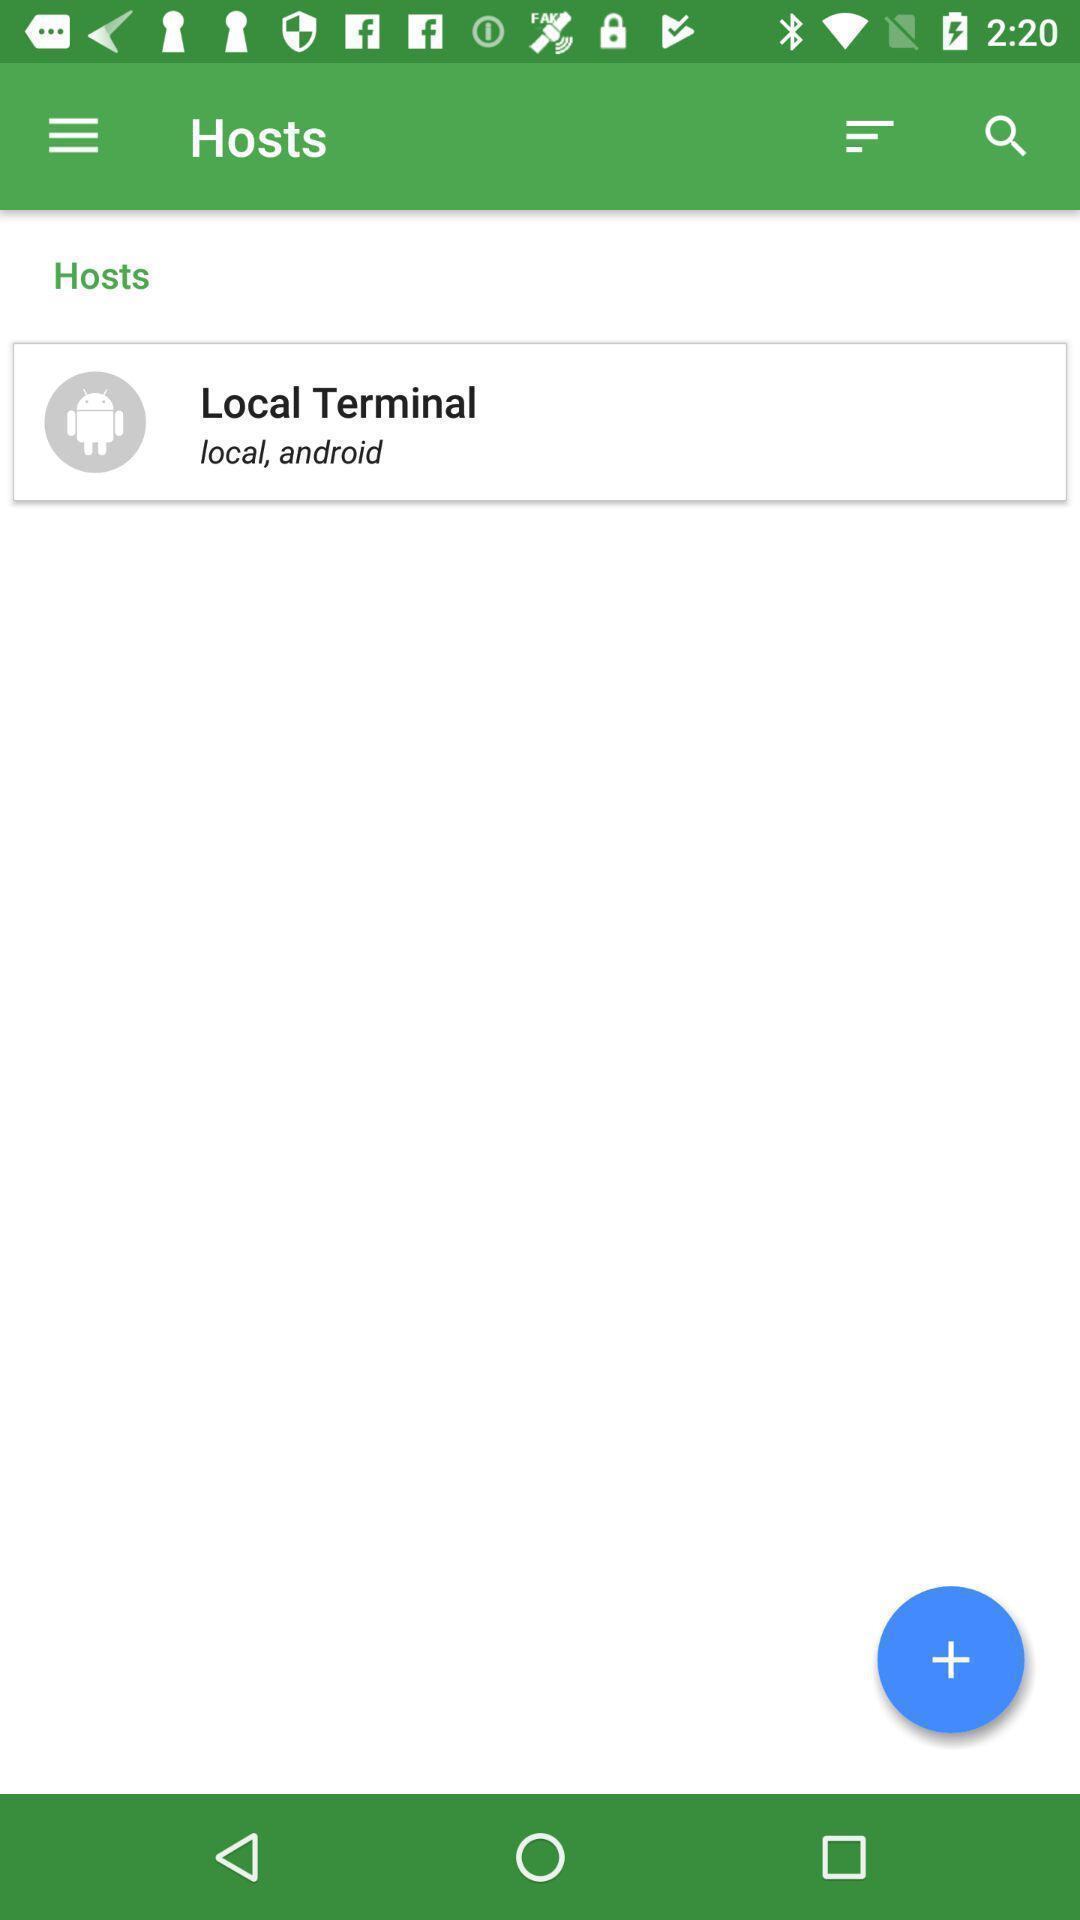Summarize the main components in this picture. Page displays hosts in app. 